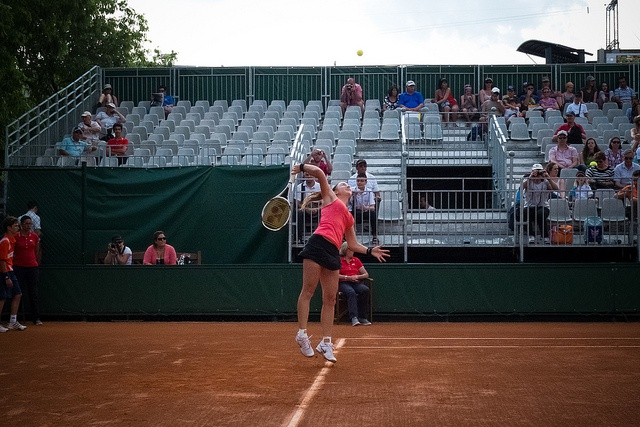Describe the objects in this image and their specific colors. I can see chair in black, gray, and darkgray tones, people in black, maroon, and brown tones, people in black, maroon, gray, and brown tones, people in black, gray, and navy tones, and tennis racket in black, gray, and darkgray tones in this image. 